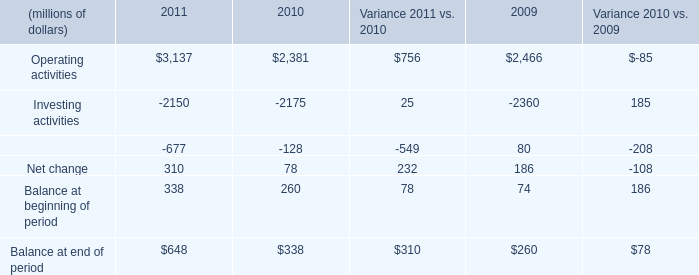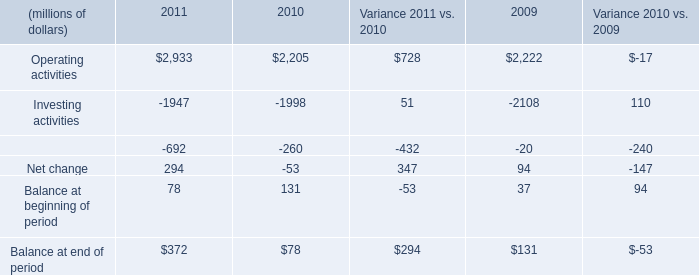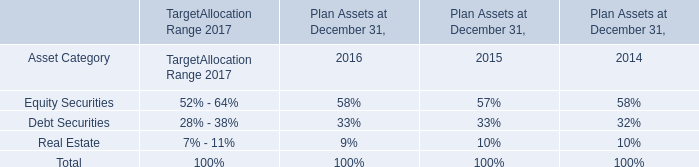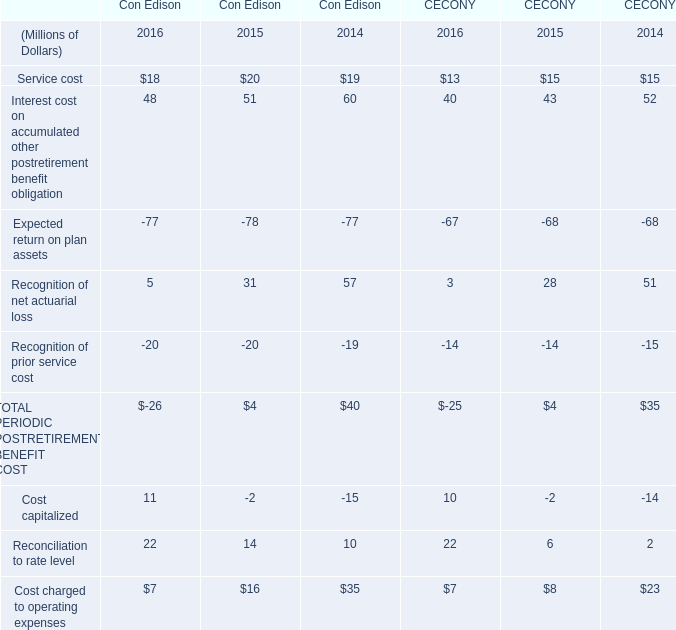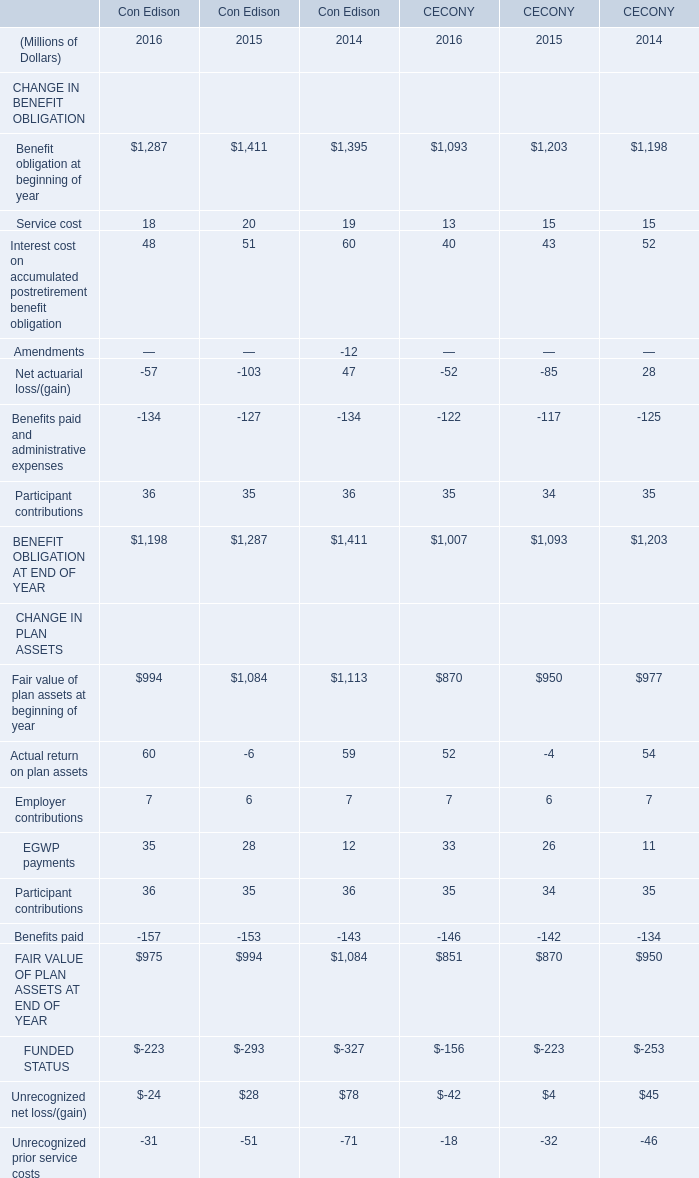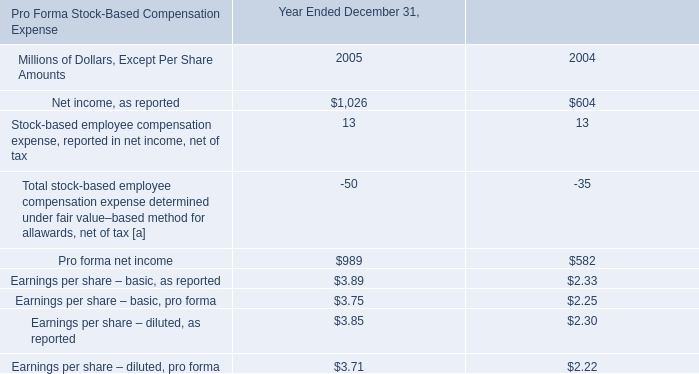Does service cost keeps increasing each year between 2014 and 2016? 
Answer: No. 